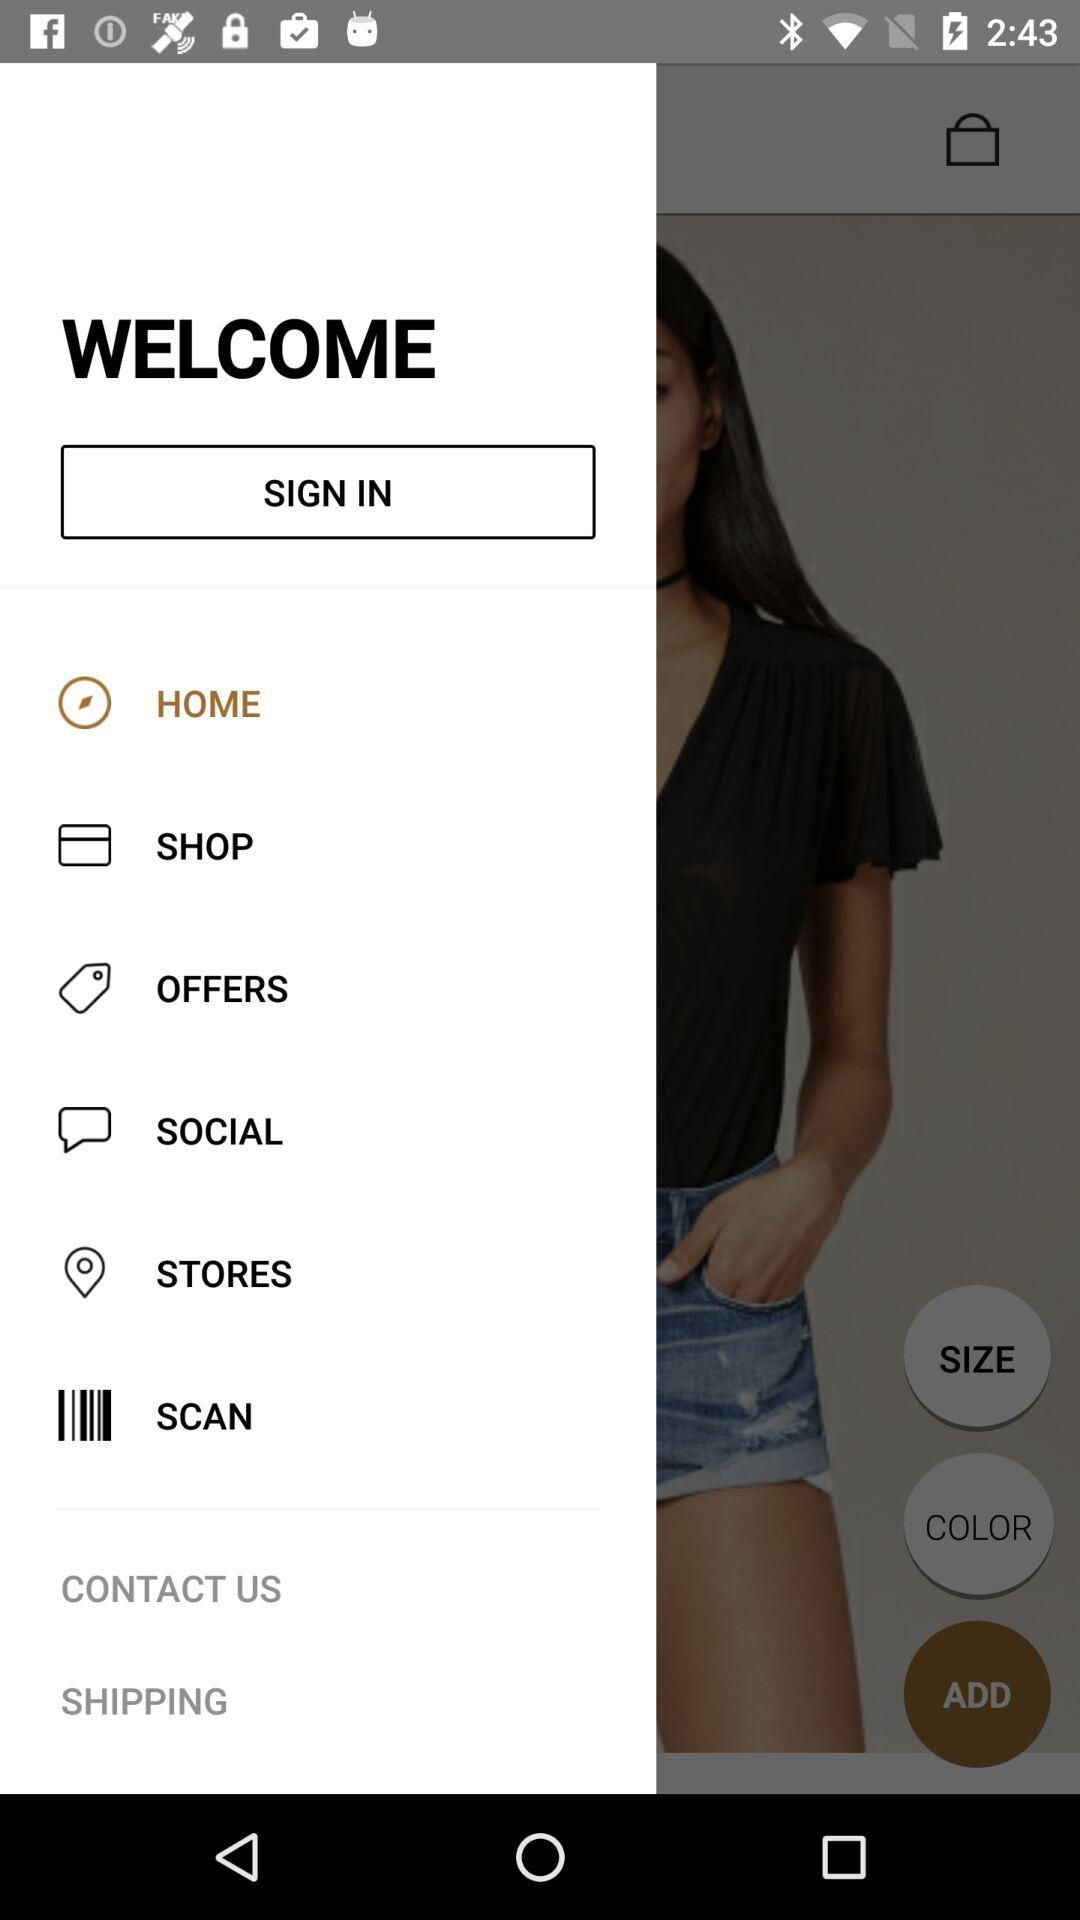Which item has been selected? The item that has been selected is "HOME". 